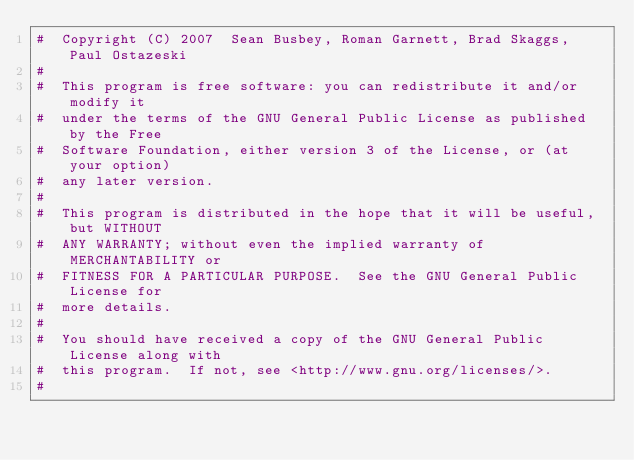Convert code to text. <code><loc_0><loc_0><loc_500><loc_500><_Awk_>#  Copyright (C) 2007  Sean Busbey, Roman Garnett, Brad Skaggs, Paul Ostazeski
#  
#  This program is free software: you can redistribute it and/or modify it
#  under the terms of the GNU General Public License as published by the Free
#  Software Foundation, either version 3 of the License, or (at your option)
#  any later version.
#  
#  This program is distributed in the hope that it will be useful, but WITHOUT
#  ANY WARRANTY; without even the implied warranty of MERCHANTABILITY or
#  FITNESS FOR A PARTICULAR PURPOSE.  See the GNU General Public License for
#  more details.
#  
#  You should have received a copy of the GNU General Public License along with
#  this program.  If not, see <http://www.gnu.org/licenses/>.
#  </code> 